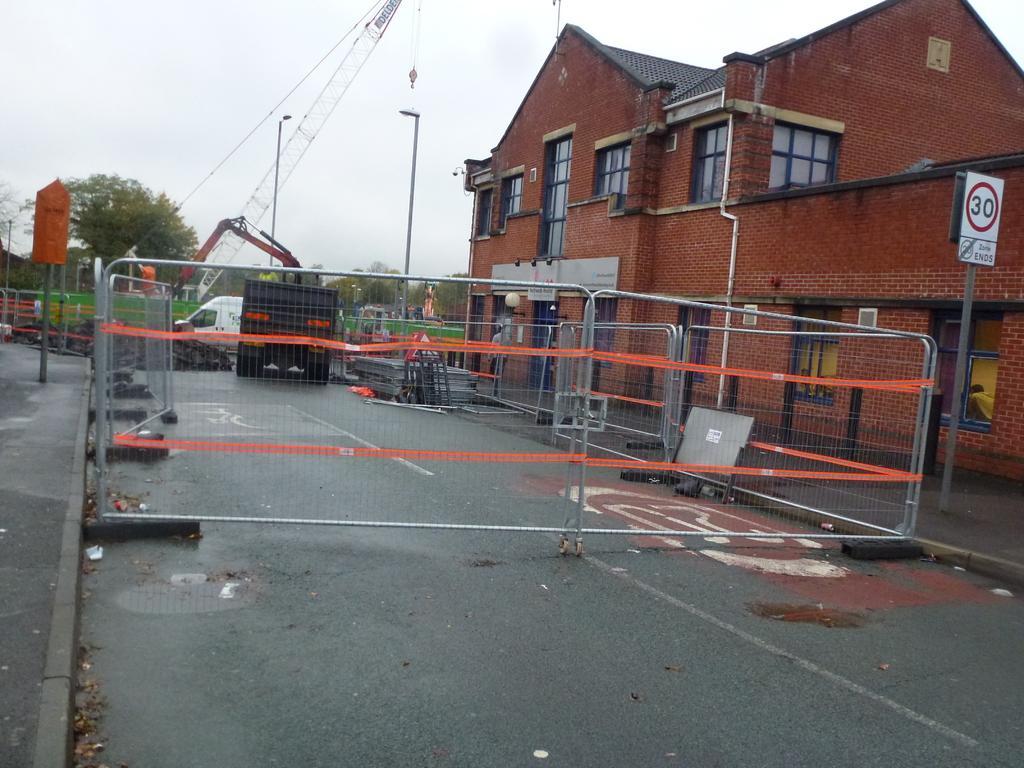Describe this image in one or two sentences. In the background we can see sky and trees. At the right side of the picture we can see a building. Here we can see poles with lights. This is a board. We can see vehicles on the road. 